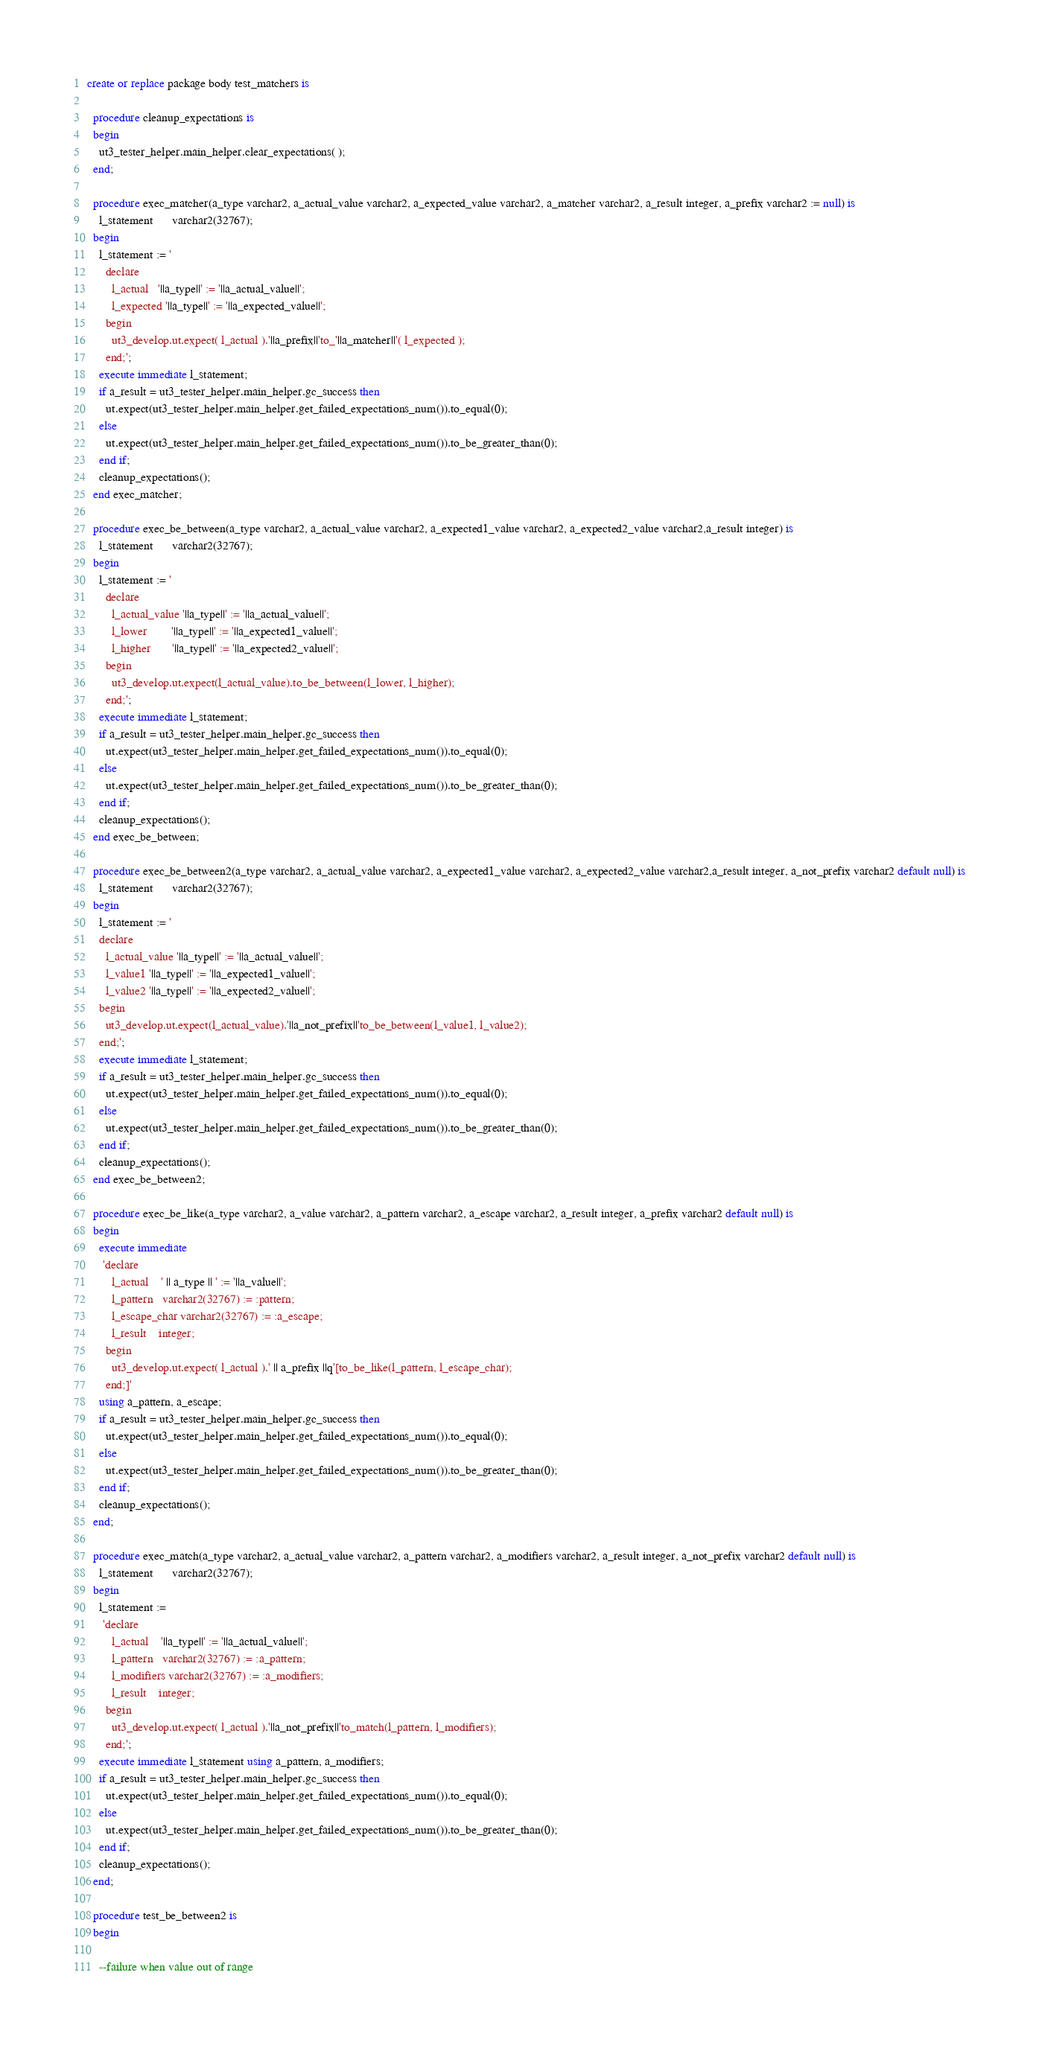Convert code to text. <code><loc_0><loc_0><loc_500><loc_500><_SQL_>create or replace package body test_matchers is

  procedure cleanup_expectations is
  begin
    ut3_tester_helper.main_helper.clear_expectations( );
  end;

  procedure exec_matcher(a_type varchar2, a_actual_value varchar2, a_expected_value varchar2, a_matcher varchar2, a_result integer, a_prefix varchar2 := null) is
    l_statement      varchar2(32767);
  begin
    l_statement := '
      declare
        l_actual   '||a_type||' := '||a_actual_value||';
        l_expected '||a_type||' := '||a_expected_value||';
      begin
        ut3_develop.ut.expect( l_actual ).'||a_prefix||'to_'||a_matcher||'( l_expected );
      end;';
    execute immediate l_statement;
    if a_result = ut3_tester_helper.main_helper.gc_success then
      ut.expect(ut3_tester_helper.main_helper.get_failed_expectations_num()).to_equal(0);
    else
      ut.expect(ut3_tester_helper.main_helper.get_failed_expectations_num()).to_be_greater_than(0);
    end if;
    cleanup_expectations();
  end exec_matcher;

  procedure exec_be_between(a_type varchar2, a_actual_value varchar2, a_expected1_value varchar2, a_expected2_value varchar2,a_result integer) is
    l_statement      varchar2(32767);
  begin
    l_statement := '
      declare
        l_actual_value '||a_type||' := '||a_actual_value||';
        l_lower        '||a_type||' := '||a_expected1_value||';
        l_higher       '||a_type||' := '||a_expected2_value||';
      begin
        ut3_develop.ut.expect(l_actual_value).to_be_between(l_lower, l_higher);
      end;';
    execute immediate l_statement;
    if a_result = ut3_tester_helper.main_helper.gc_success then
      ut.expect(ut3_tester_helper.main_helper.get_failed_expectations_num()).to_equal(0);
    else
      ut.expect(ut3_tester_helper.main_helper.get_failed_expectations_num()).to_be_greater_than(0);
    end if;
    cleanup_expectations();
  end exec_be_between;

  procedure exec_be_between2(a_type varchar2, a_actual_value varchar2, a_expected1_value varchar2, a_expected2_value varchar2,a_result integer, a_not_prefix varchar2 default null) is
    l_statement      varchar2(32767);
  begin
    l_statement := '
    declare
      l_actual_value '||a_type||' := '||a_actual_value||';
      l_value1 '||a_type||' := '||a_expected1_value||';
      l_value2 '||a_type||' := '||a_expected2_value||';
    begin
      ut3_develop.ut.expect(l_actual_value).'||a_not_prefix||'to_be_between(l_value1, l_value2);
    end;';
    execute immediate l_statement;
    if a_result = ut3_tester_helper.main_helper.gc_success then
      ut.expect(ut3_tester_helper.main_helper.get_failed_expectations_num()).to_equal(0);
    else
      ut.expect(ut3_tester_helper.main_helper.get_failed_expectations_num()).to_be_greater_than(0);
    end if;
    cleanup_expectations();
  end exec_be_between2;

  procedure exec_be_like(a_type varchar2, a_value varchar2, a_pattern varchar2, a_escape varchar2, a_result integer, a_prefix varchar2 default null) is
  begin
    execute immediate
     'declare
        l_actual    ' || a_type || ' := '||a_value||';
        l_pattern   varchar2(32767) := :pattern;
        l_escape_char varchar2(32767) := :a_escape;
        l_result    integer;
      begin
        ut3_develop.ut.expect( l_actual ).' || a_prefix ||q'[to_be_like(l_pattern, l_escape_char);
      end;]'
    using a_pattern, a_escape;
    if a_result = ut3_tester_helper.main_helper.gc_success then
      ut.expect(ut3_tester_helper.main_helper.get_failed_expectations_num()).to_equal(0);
    else
      ut.expect(ut3_tester_helper.main_helper.get_failed_expectations_num()).to_be_greater_than(0);
    end if;
    cleanup_expectations();
  end;
  
  procedure exec_match(a_type varchar2, a_actual_value varchar2, a_pattern varchar2, a_modifiers varchar2, a_result integer, a_not_prefix varchar2 default null) is
    l_statement      varchar2(32767);
  begin
    l_statement :=
     'declare
        l_actual    '||a_type||' := '||a_actual_value||';
        l_pattern   varchar2(32767) := :a_pattern;
        l_modifiers varchar2(32767) := :a_modifiers;
        l_result    integer;
      begin
        ut3_develop.ut.expect( l_actual ).'||a_not_prefix||'to_match(l_pattern, l_modifiers);
      end;';
    execute immediate l_statement using a_pattern, a_modifiers;
    if a_result = ut3_tester_helper.main_helper.gc_success then
      ut.expect(ut3_tester_helper.main_helper.get_failed_expectations_num()).to_equal(0);
    else
      ut.expect(ut3_tester_helper.main_helper.get_failed_expectations_num()).to_be_greater_than(0);
    end if;
    cleanup_expectations();
  end;

  procedure test_be_between2 is
  begin

    --failure when value out of range</code> 